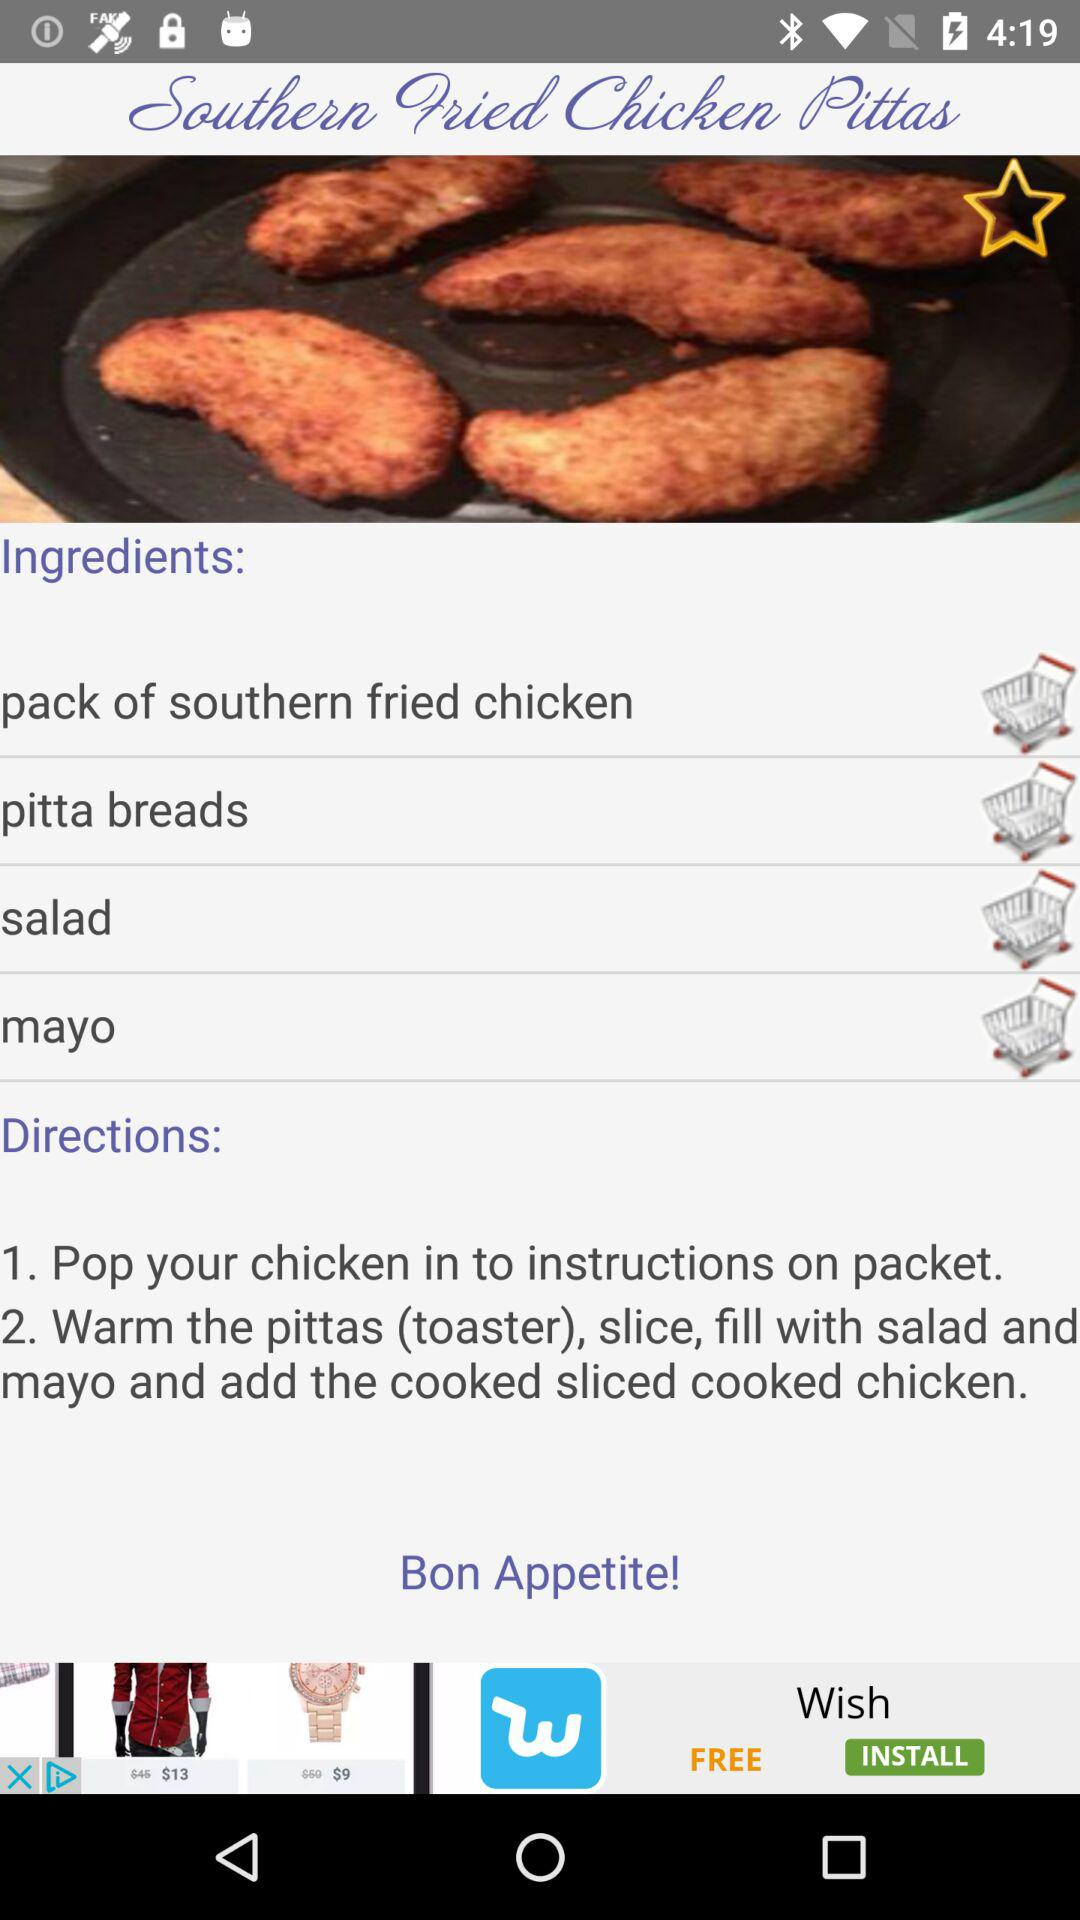What are the directions? The directions are "Pop your chicken in to instructions on packet" and "Warm the pittas (toaster), slice, fill with salad and mayo and add the cooked sliced cooked chicken". 